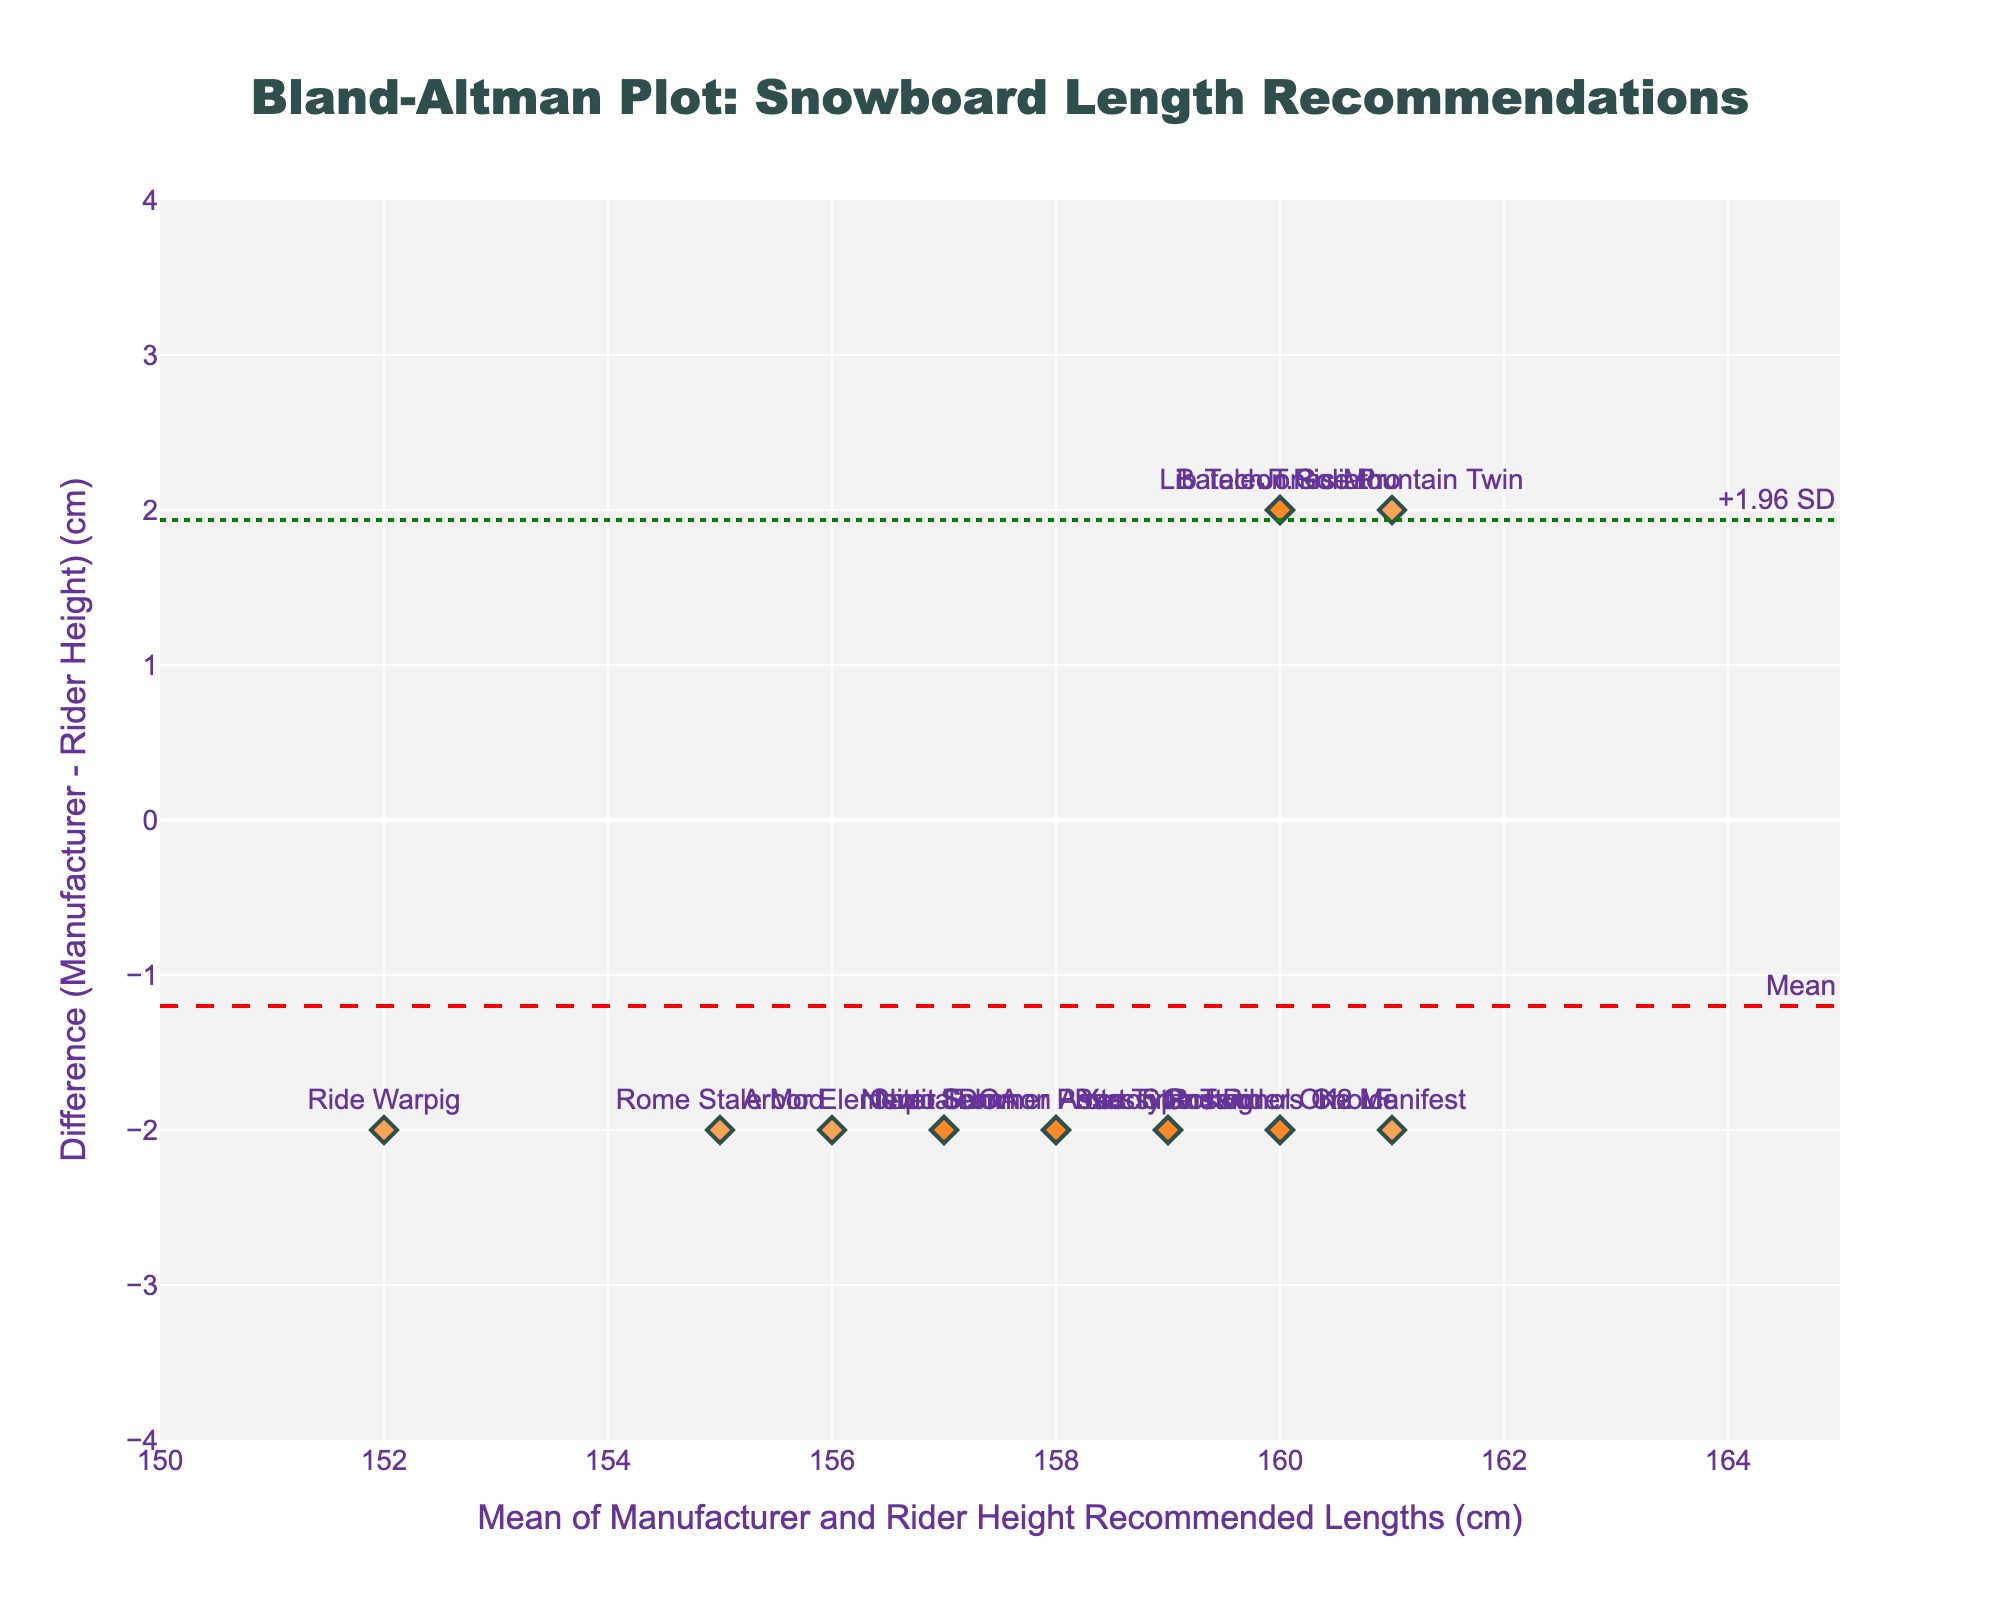What's the title of the plot? The title is typically located at the top center of the plot. It summarizes what the plot represents. By observation, the title reads: "Bland-Altman Plot: Snowboard Length Recommendations"
Answer: Bland-Altman Plot: Snowboard Length Recommendations What do the x-axis and y-axis represent in this plot? The x-axis title "Mean of Manufacturer and Rider Height Recommended Lengths (cm)" indicates that it shows the average length recommended by manufacturers and rider heights. The y-axis title "Difference (Manufacturer - Rider Height) (cm)" indicates that it shows the difference between the manufacturer-recommended length and the rider height recommended length.
Answer: x-axis: Mean of Manufacturer and Rider Height Recommended Lengths (cm); y-axis: Difference (Manufacturer - Rider Height) (cm) How many data points are displayed in the plot? Count the number of unique markers (points) displayed on the plot. Since each snowboard model is labeled, count the snowboard models. There are 15 unique models: Burton Custom, Lib Tech T.Rice Pro, Arbor Element, etc.
Answer: 15 What's the mean difference between the manufacturer recommended length and rider height recommended length? The mean difference is indicated by the dashed red line annotated as "Mean". By checking the annotation next to the red line, we find it labeled "Mean".
Answer: 0 Which snowboard model has the largest positive difference between manufacturer recommended length and rider height recommended length? Look for the point with the highest position on the y-axis. The scatter plot shows labels of snowboard models, and the highest point is labeled "Bataleon Goliath".
Answer: Bataleon Goliath What are the upper and lower limits of agreement (LOA) in the plot? The limits of agreement are indicated by the green dotted lines. By checking the annotations next to the green lines labelled "+1.96 SD" and "-1.96 SD", we get the values by observing their corresponding y-values.
Answer: Upper LOA: 1.73; Lower LOA: -1.73 What is the difference in the recommended length for the K2 Manifest model? Locate the label "K2 Manifest" on the scatter plot to find its position. Check the y-coordinate of the point associated with this label. The y-coordinate represents the difference.
Answer: -2 Is there any snowboard model where the manufacturer recommended length is equal to the rider height recommended length? A point with a difference of 0 on the y-axis would mean the manufacturer and rider height recommended lengths are equal. The label of the point at y=0 will provide the model names. There is no point at y=0.
Answer: No Among "Burton Custom" and "Jones Mountain Twin", which model has a greater difference between the lengths? Identify the points for "Burton Custom" and "Jones Mountain Twin" on the scatter plot. Compare their y-coordinates. "Burton Custom" is at y=-2 and "Jones Mountain Twin" is at y=2, indicating that the latter has a greater difference.
Answer: Jones Mountain Twin 